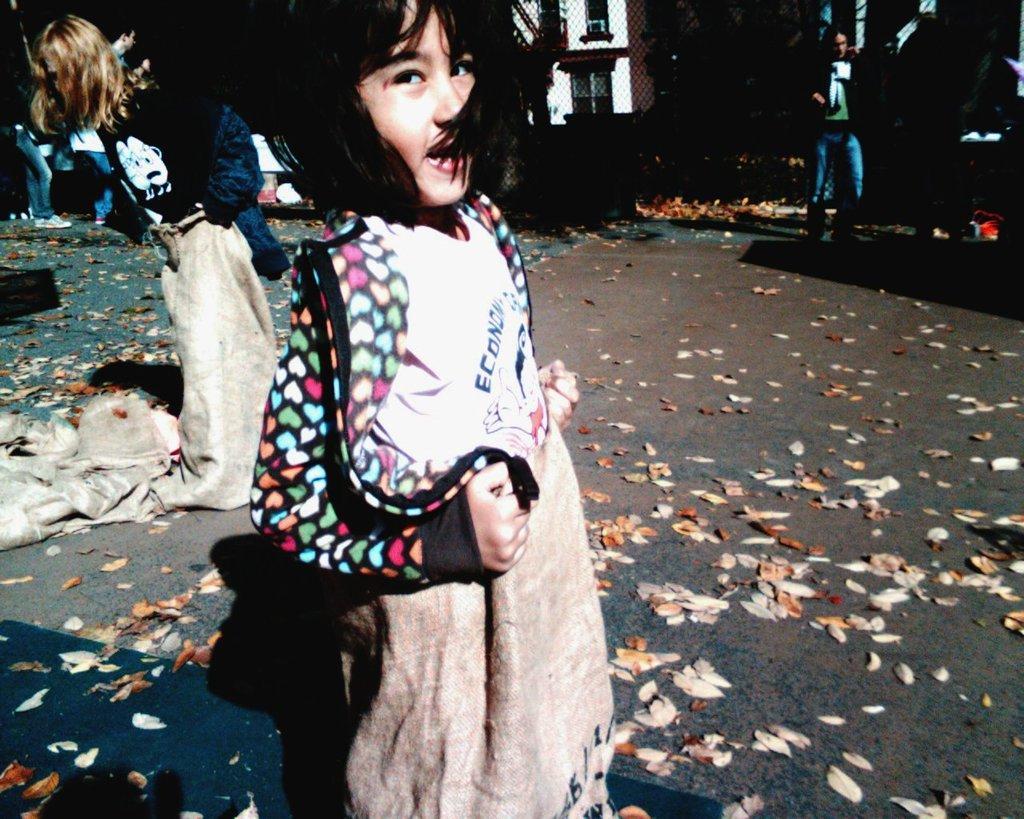Can you describe this image briefly? In the foreground of the picture there is a girl, she is standing in a sack. On the left there is another girl in the sack. In the foreground it is road, on the road there are dry leaves. On the right there are people standing on the road. In the center of the background we can see fencing and building. In the background towards left we can see people and other objects. 